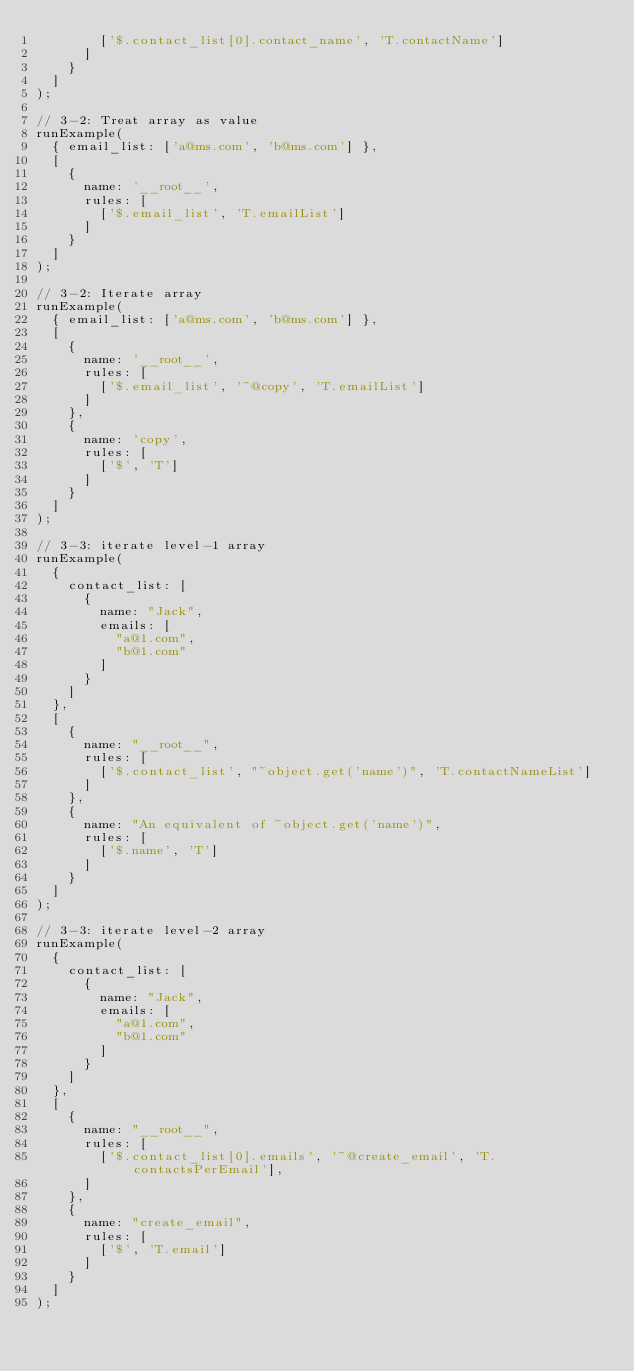<code> <loc_0><loc_0><loc_500><loc_500><_TypeScript_>        ['$.contact_list[0].contact_name', 'T.contactName']
      ]
    }
  ]
);

// 3-2: Treat array as value
runExample(
  { email_list: ['a@ms.com', 'b@ms.com'] },
  [
    {
      name: '__root__',
      rules: [
        ['$.email_list', 'T.emailList']
      ]
    }
  ]
);

// 3-2: Iterate array
runExample(
  { email_list: ['a@ms.com', 'b@ms.com'] },
  [
    {
      name: '__root__',
      rules: [
        ['$.email_list', '~@copy', 'T.emailList']
      ]
    },
    {
      name: 'copy',
      rules: [
        ['$', 'T']
      ]
    }
  ]
);

// 3-3: iterate level-1 array
runExample(
  {
    contact_list: [
      {
        name: "Jack",
        emails: [
          "a@1.com",
          "b@1.com"
        ]
      }
    ]
  },
  [
    {
      name: "__root__",
      rules: [
        ['$.contact_list', "~object.get('name')", 'T.contactNameList']
      ]
    },
    {
      name: "An equivalent of ~object.get('name')",
      rules: [
        ['$.name', 'T']
      ]
    }
  ]
);

// 3-3: iterate level-2 array
runExample(
  {
    contact_list: [
      {
        name: "Jack",
        emails: [
          "a@1.com",
          "b@1.com"
        ]
      }
    ]
  },
  [
    {
      name: "__root__",
      rules: [
        ['$.contact_list[0].emails', '~@create_email', 'T.contactsPerEmail'],
      ]
    },
    {
      name: "create_email",
      rules: [
        ['$', 'T.email']
      ]
    }
  ]
);</code> 